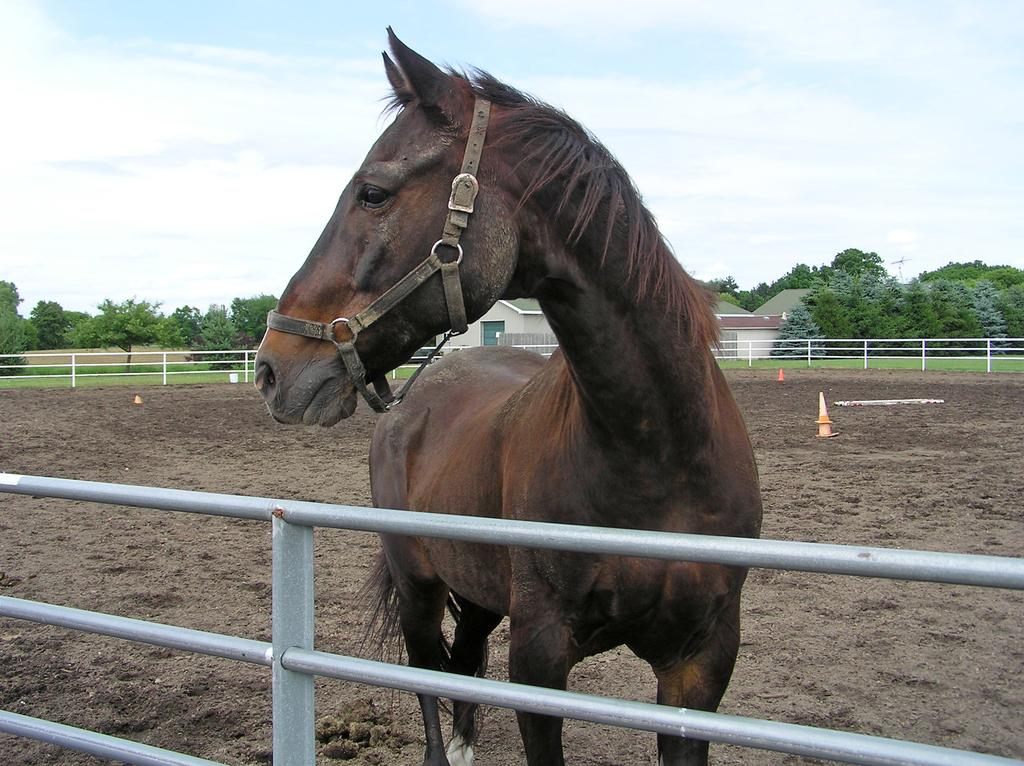What is the main subject in the center of the image? There is a horse in the center of the image. What is the horse positioned in relation to? The horse is in front of a boundary. What can be seen in the background of the image? There are houses and trees in the background of the image. How many trains can be seen passing by the horse in the image? There are no trains present in the image; it features a horse in front of a boundary with houses and trees in the background. 